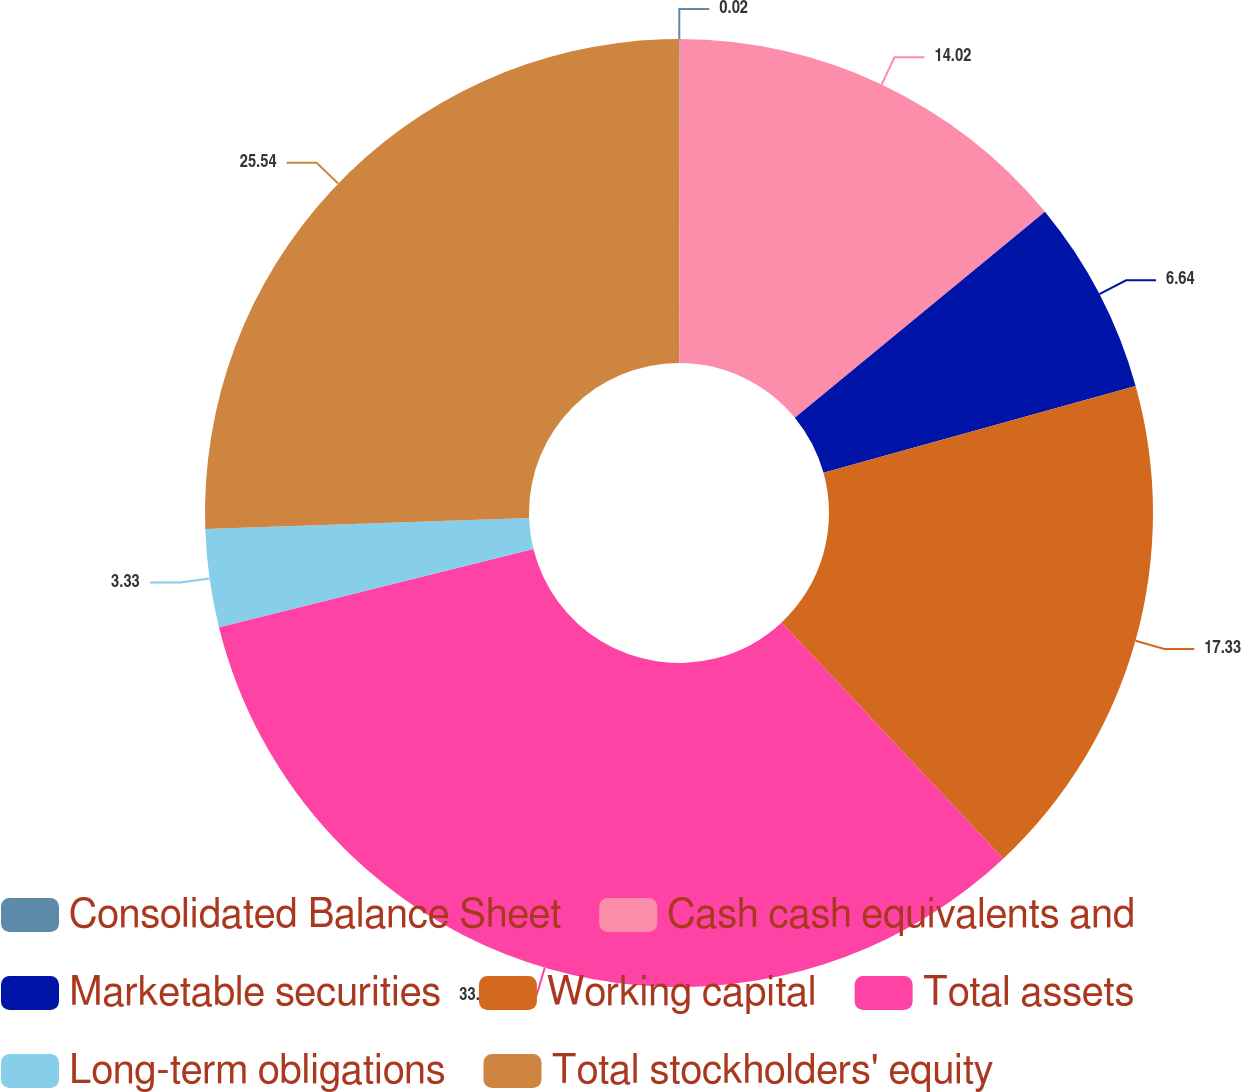Convert chart. <chart><loc_0><loc_0><loc_500><loc_500><pie_chart><fcel>Consolidated Balance Sheet<fcel>Cash cash equivalents and<fcel>Marketable securities<fcel>Working capital<fcel>Total assets<fcel>Long-term obligations<fcel>Total stockholders' equity<nl><fcel>0.02%<fcel>14.02%<fcel>6.64%<fcel>17.33%<fcel>33.12%<fcel>3.33%<fcel>25.54%<nl></chart> 